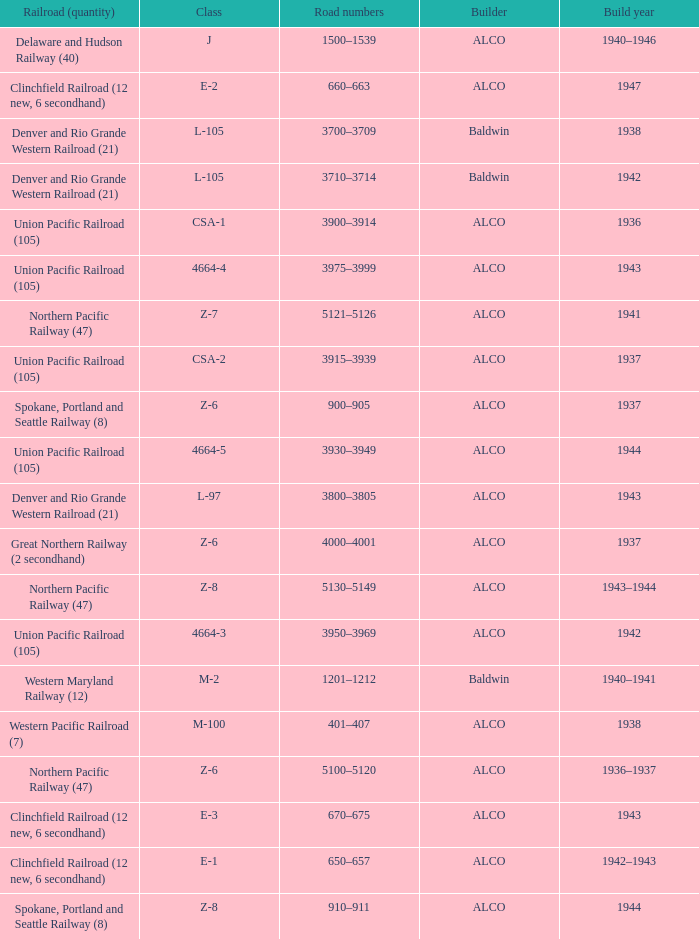What is the road numbers when the builder is alco, the railroad (quantity) is union pacific railroad (105) and the class is csa-2? 3915–3939. 